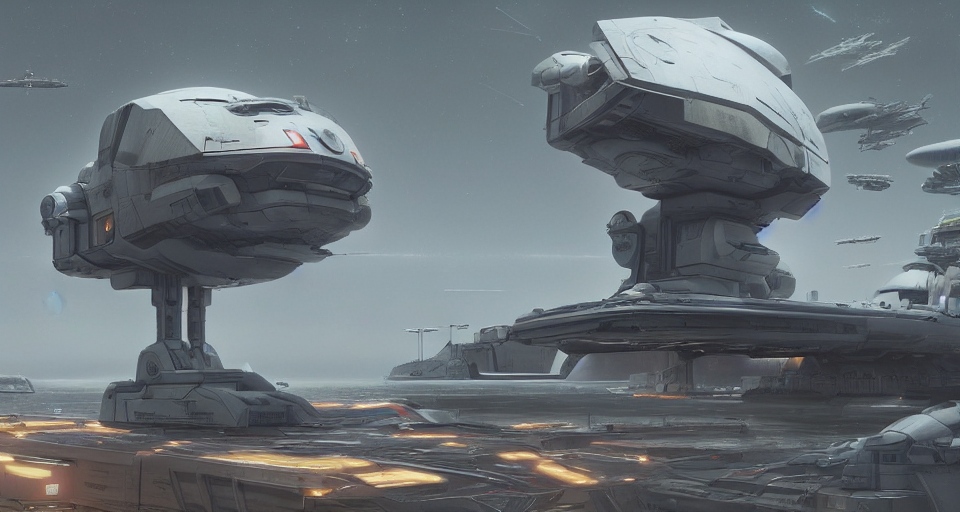How would you interpret the overall atmosphere of this image? The image conveys a solemn and somewhat monochromatic atmosphere, implying a heavy industrial presence. The overcast sky and artificial lighting create a feeling of perpetual twilight, hinting at a world where technology and function outweigh natural elements and perhaps even human comfort. 